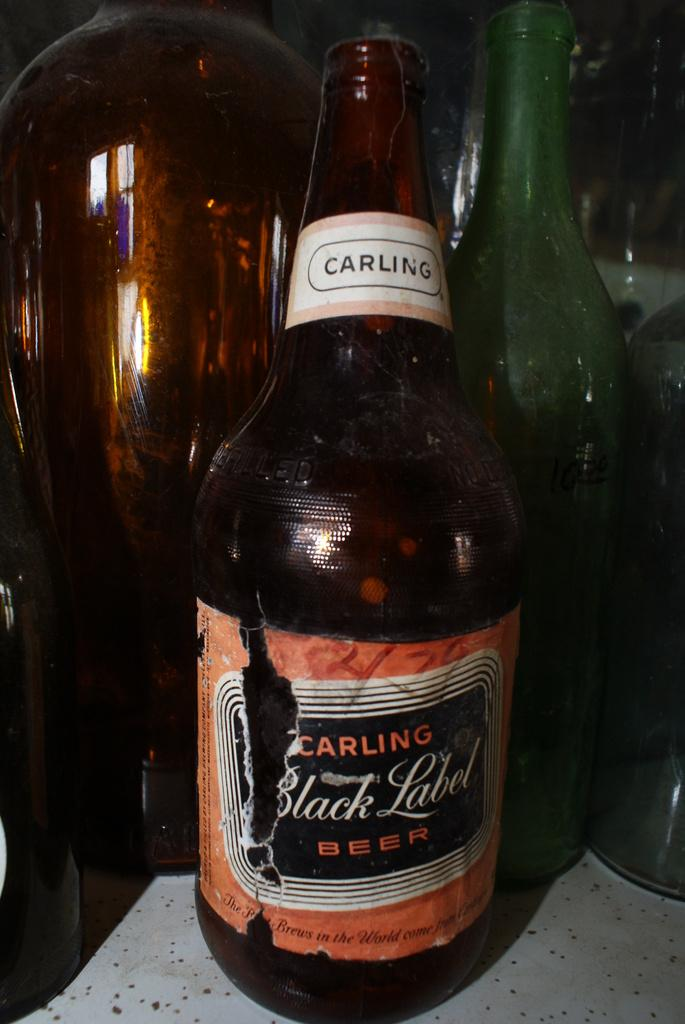<image>
Describe the image concisely. Several bottles are on the table one of the bottles is a Carling Black Label Beer bottle. 